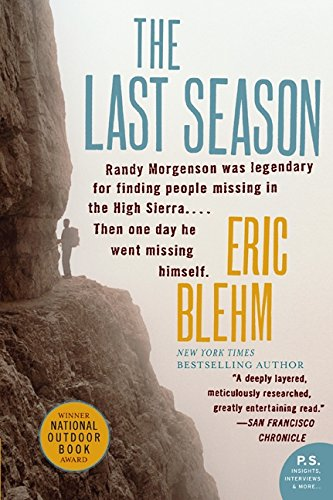What type of book is this? 'The Last Season' is primarily a biographical and adventure book, detailing the life and mysterious disappearance of a park ranger in the Sierra Nevada mountains. 